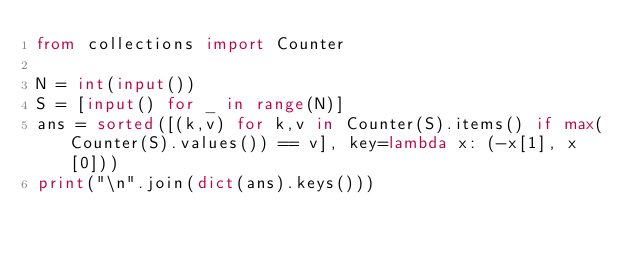Convert code to text. <code><loc_0><loc_0><loc_500><loc_500><_Python_>from collections import Counter

N = int(input())
S = [input() for _ in range(N)]
ans = sorted([(k,v) for k,v in Counter(S).items() if max(Counter(S).values()) == v], key=lambda x: (-x[1], x[0]))
print("\n".join(dict(ans).keys()))</code> 